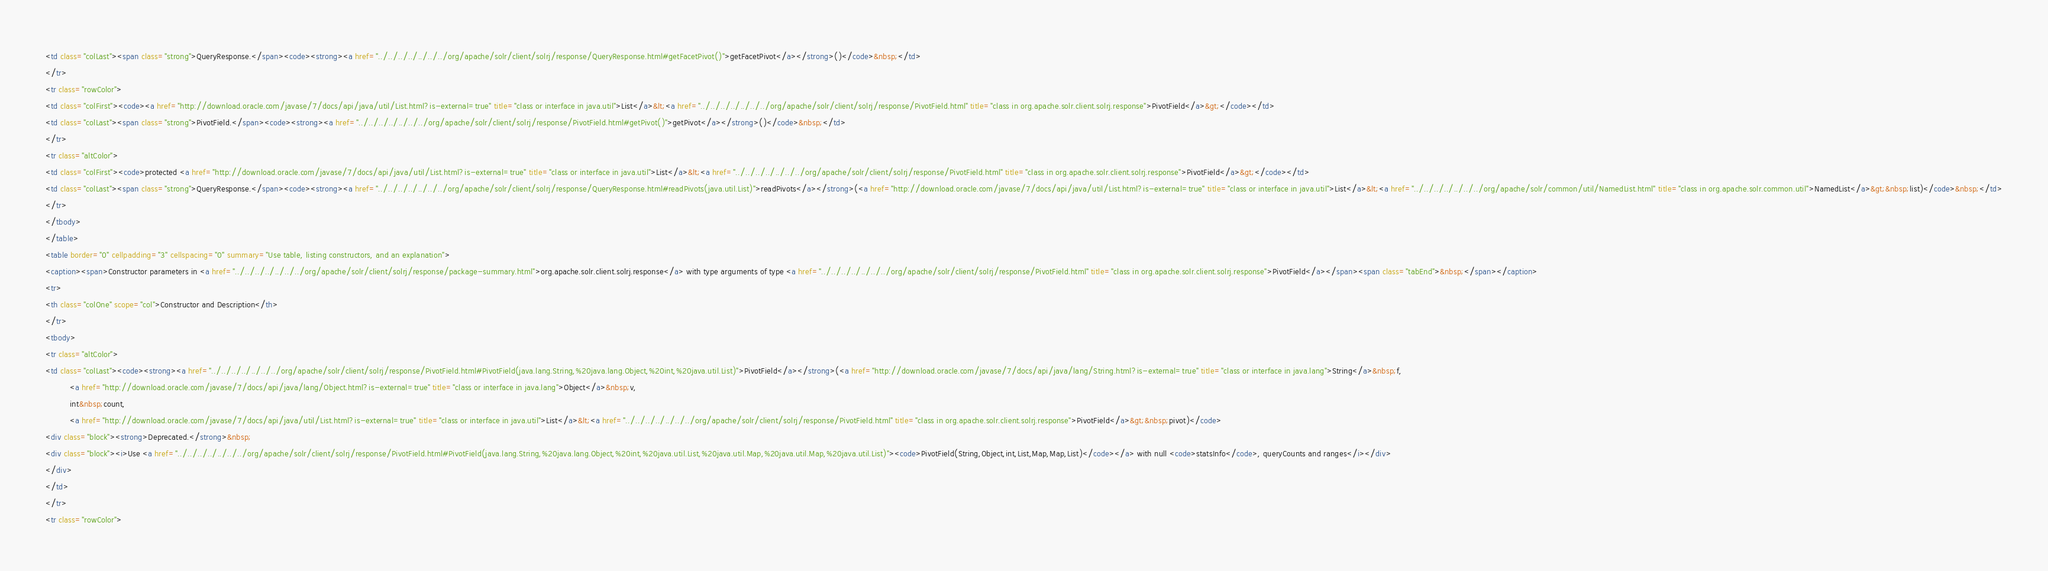<code> <loc_0><loc_0><loc_500><loc_500><_HTML_><td class="colLast"><span class="strong">QueryResponse.</span><code><strong><a href="../../../../../../../org/apache/solr/client/solrj/response/QueryResponse.html#getFacetPivot()">getFacetPivot</a></strong>()</code>&nbsp;</td>
</tr>
<tr class="rowColor">
<td class="colFirst"><code><a href="http://download.oracle.com/javase/7/docs/api/java/util/List.html?is-external=true" title="class or interface in java.util">List</a>&lt;<a href="../../../../../../../org/apache/solr/client/solrj/response/PivotField.html" title="class in org.apache.solr.client.solrj.response">PivotField</a>&gt;</code></td>
<td class="colLast"><span class="strong">PivotField.</span><code><strong><a href="../../../../../../../org/apache/solr/client/solrj/response/PivotField.html#getPivot()">getPivot</a></strong>()</code>&nbsp;</td>
</tr>
<tr class="altColor">
<td class="colFirst"><code>protected <a href="http://download.oracle.com/javase/7/docs/api/java/util/List.html?is-external=true" title="class or interface in java.util">List</a>&lt;<a href="../../../../../../../org/apache/solr/client/solrj/response/PivotField.html" title="class in org.apache.solr.client.solrj.response">PivotField</a>&gt;</code></td>
<td class="colLast"><span class="strong">QueryResponse.</span><code><strong><a href="../../../../../../../org/apache/solr/client/solrj/response/QueryResponse.html#readPivots(java.util.List)">readPivots</a></strong>(<a href="http://download.oracle.com/javase/7/docs/api/java/util/List.html?is-external=true" title="class or interface in java.util">List</a>&lt;<a href="../../../../../../../org/apache/solr/common/util/NamedList.html" title="class in org.apache.solr.common.util">NamedList</a>&gt;&nbsp;list)</code>&nbsp;</td>
</tr>
</tbody>
</table>
<table border="0" cellpadding="3" cellspacing="0" summary="Use table, listing constructors, and an explanation">
<caption><span>Constructor parameters in <a href="../../../../../../../org/apache/solr/client/solrj/response/package-summary.html">org.apache.solr.client.solrj.response</a> with type arguments of type <a href="../../../../../../../org/apache/solr/client/solrj/response/PivotField.html" title="class in org.apache.solr.client.solrj.response">PivotField</a></span><span class="tabEnd">&nbsp;</span></caption>
<tr>
<th class="colOne" scope="col">Constructor and Description</th>
</tr>
<tbody>
<tr class="altColor">
<td class="colLast"><code><strong><a href="../../../../../../../org/apache/solr/client/solrj/response/PivotField.html#PivotField(java.lang.String,%20java.lang.Object,%20int,%20java.util.List)">PivotField</a></strong>(<a href="http://download.oracle.com/javase/7/docs/api/java/lang/String.html?is-external=true" title="class or interface in java.lang">String</a>&nbsp;f,
          <a href="http://download.oracle.com/javase/7/docs/api/java/lang/Object.html?is-external=true" title="class or interface in java.lang">Object</a>&nbsp;v,
          int&nbsp;count,
          <a href="http://download.oracle.com/javase/7/docs/api/java/util/List.html?is-external=true" title="class or interface in java.util">List</a>&lt;<a href="../../../../../../../org/apache/solr/client/solrj/response/PivotField.html" title="class in org.apache.solr.client.solrj.response">PivotField</a>&gt;&nbsp;pivot)</code>
<div class="block"><strong>Deprecated.</strong>&nbsp;
<div class="block"><i>Use <a href="../../../../../../../org/apache/solr/client/solrj/response/PivotField.html#PivotField(java.lang.String,%20java.lang.Object,%20int,%20java.util.List,%20java.util.Map,%20java.util.Map,%20java.util.List)"><code>PivotField(String,Object,int,List,Map,Map,List)</code></a> with null <code>statsInfo</code>, queryCounts and ranges</i></div>
</div>
</td>
</tr>
<tr class="rowColor"></code> 